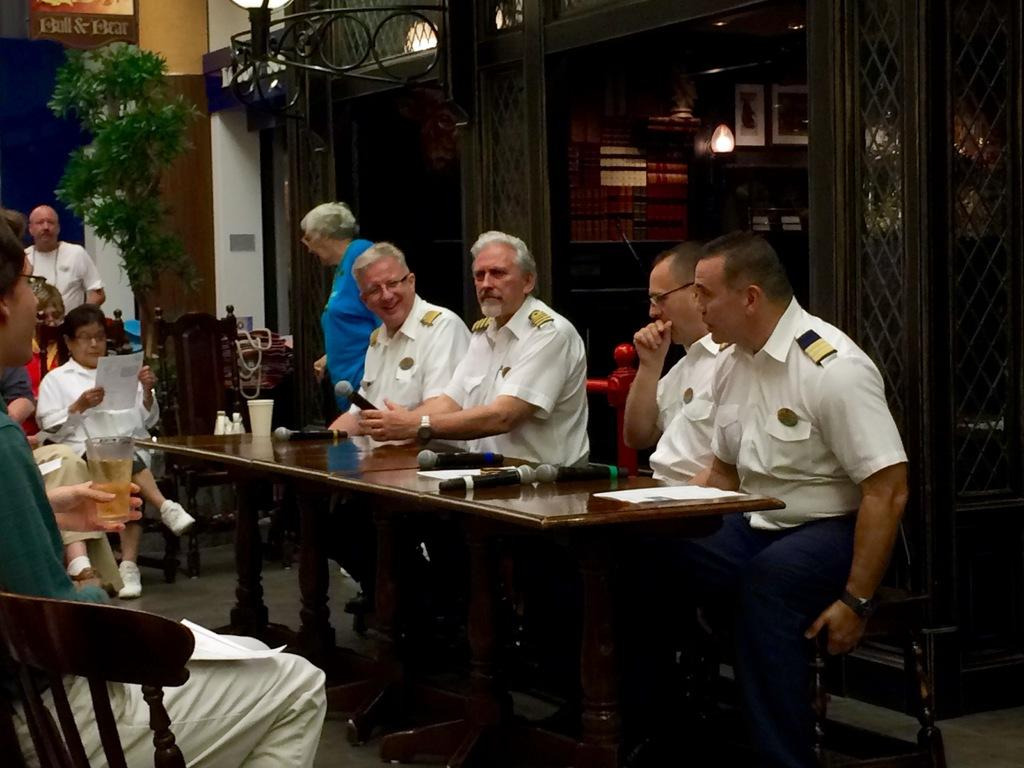What is the person in the image wearing? The person is wearing a white shirt in the image. What is the person's position in the image? The person is sitting in a chair. What is in front of the person? There is a table in front of the person. What is on the table? The table has mics and papers on it. Who is present in the image besides the person sitting in the chair? There is a group of people in front of the person. What type of fish can be seen swimming in the lettuce on the table? There is no fish or lettuce present on the table in the image; it only has mics and papers. What kind of humor is being displayed by the person in the image? The image does not provide any information about the person's sense of humor. 